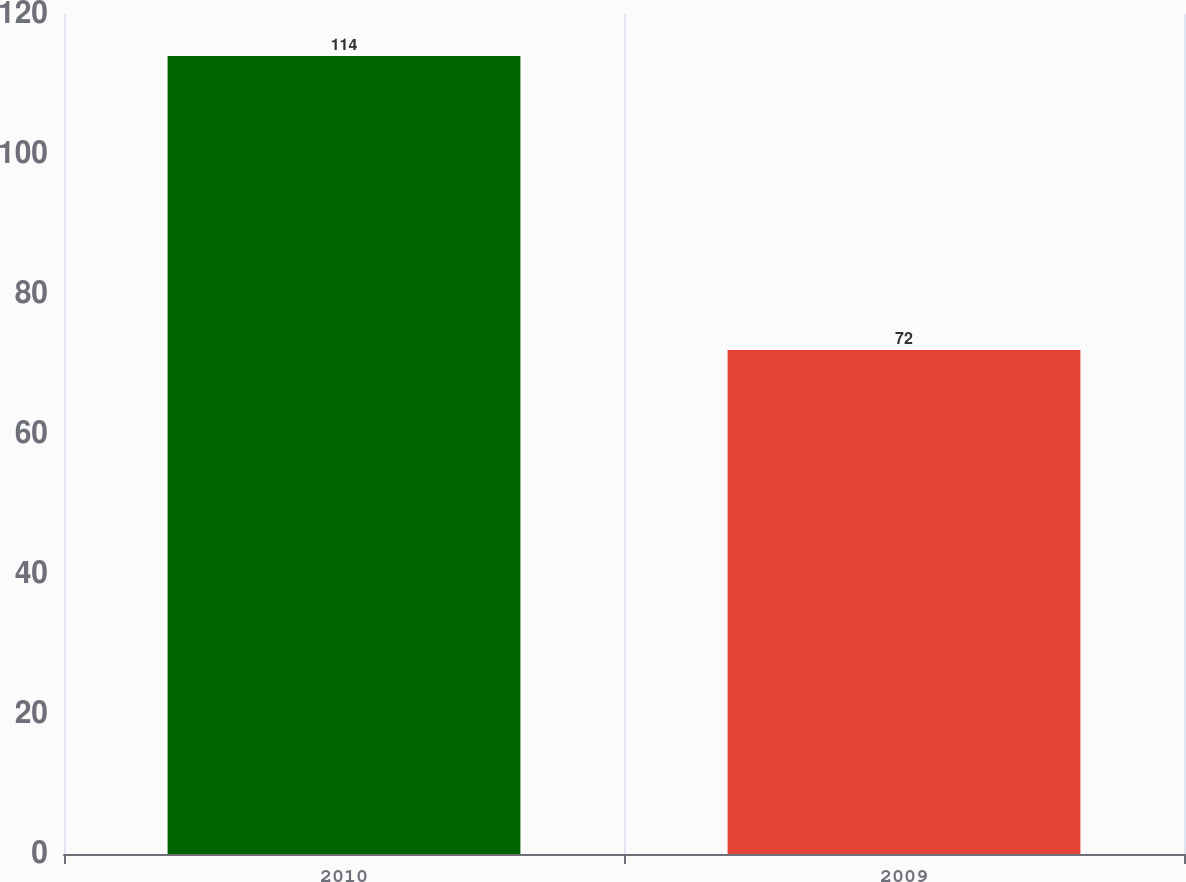Convert chart to OTSL. <chart><loc_0><loc_0><loc_500><loc_500><bar_chart><fcel>2010<fcel>2009<nl><fcel>114<fcel>72<nl></chart> 